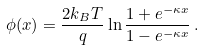<formula> <loc_0><loc_0><loc_500><loc_500>\phi ( x ) = \frac { 2 k _ { B } T } { q } \ln \frac { 1 + e ^ { - \kappa x } } { 1 - e ^ { - \kappa x } } \, .</formula> 